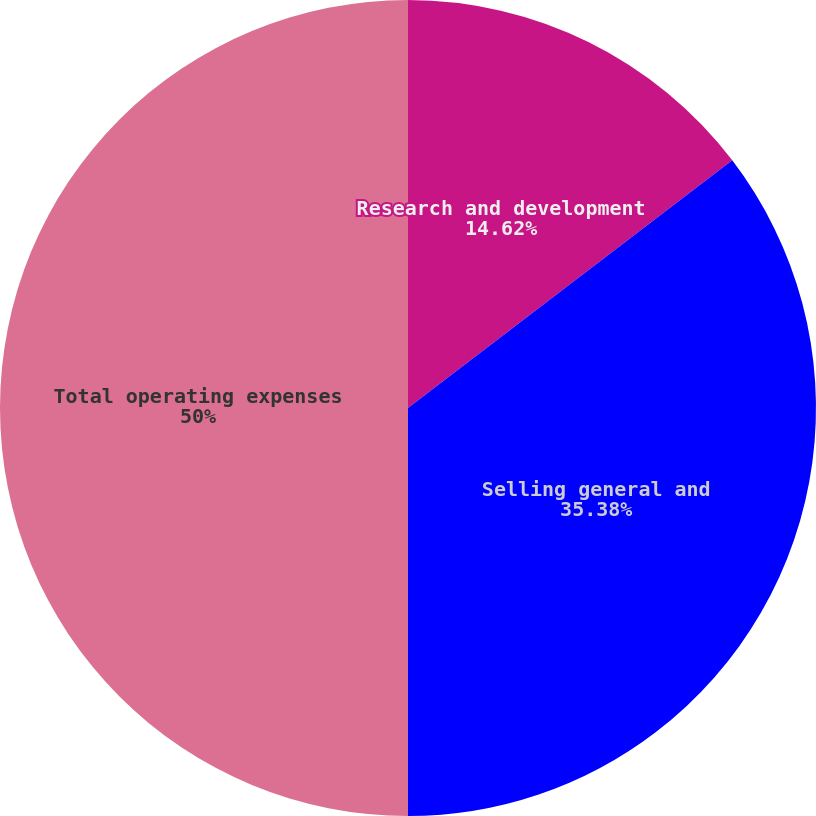Convert chart. <chart><loc_0><loc_0><loc_500><loc_500><pie_chart><fcel>Research and development<fcel>Selling general and<fcel>Total operating expenses<nl><fcel>14.62%<fcel>35.38%<fcel>50.0%<nl></chart> 